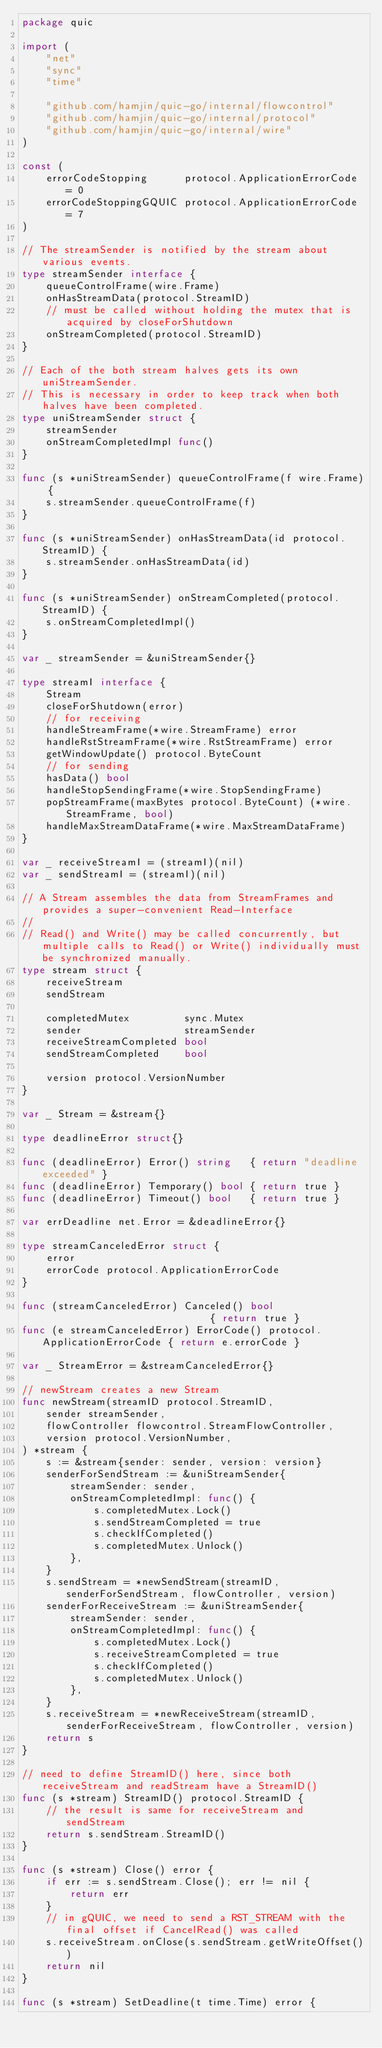<code> <loc_0><loc_0><loc_500><loc_500><_Go_>package quic

import (
	"net"
	"sync"
	"time"

	"github.com/hamjin/quic-go/internal/flowcontrol"
	"github.com/hamjin/quic-go/internal/protocol"
	"github.com/hamjin/quic-go/internal/wire"
)

const (
	errorCodeStopping      protocol.ApplicationErrorCode = 0
	errorCodeStoppingGQUIC protocol.ApplicationErrorCode = 7
)

// The streamSender is notified by the stream about various events.
type streamSender interface {
	queueControlFrame(wire.Frame)
	onHasStreamData(protocol.StreamID)
	// must be called without holding the mutex that is acquired by closeForShutdown
	onStreamCompleted(protocol.StreamID)
}

// Each of the both stream halves gets its own uniStreamSender.
// This is necessary in order to keep track when both halves have been completed.
type uniStreamSender struct {
	streamSender
	onStreamCompletedImpl func()
}

func (s *uniStreamSender) queueControlFrame(f wire.Frame) {
	s.streamSender.queueControlFrame(f)
}

func (s *uniStreamSender) onHasStreamData(id protocol.StreamID) {
	s.streamSender.onHasStreamData(id)
}

func (s *uniStreamSender) onStreamCompleted(protocol.StreamID) {
	s.onStreamCompletedImpl()
}

var _ streamSender = &uniStreamSender{}

type streamI interface {
	Stream
	closeForShutdown(error)
	// for receiving
	handleStreamFrame(*wire.StreamFrame) error
	handleRstStreamFrame(*wire.RstStreamFrame) error
	getWindowUpdate() protocol.ByteCount
	// for sending
	hasData() bool
	handleStopSendingFrame(*wire.StopSendingFrame)
	popStreamFrame(maxBytes protocol.ByteCount) (*wire.StreamFrame, bool)
	handleMaxStreamDataFrame(*wire.MaxStreamDataFrame)
}

var _ receiveStreamI = (streamI)(nil)
var _ sendStreamI = (streamI)(nil)

// A Stream assembles the data from StreamFrames and provides a super-convenient Read-Interface
//
// Read() and Write() may be called concurrently, but multiple calls to Read() or Write() individually must be synchronized manually.
type stream struct {
	receiveStream
	sendStream

	completedMutex         sync.Mutex
	sender                 streamSender
	receiveStreamCompleted bool
	sendStreamCompleted    bool

	version protocol.VersionNumber
}

var _ Stream = &stream{}

type deadlineError struct{}

func (deadlineError) Error() string   { return "deadline exceeded" }
func (deadlineError) Temporary() bool { return true }
func (deadlineError) Timeout() bool   { return true }

var errDeadline net.Error = &deadlineError{}

type streamCanceledError struct {
	error
	errorCode protocol.ApplicationErrorCode
}

func (streamCanceledError) Canceled() bool                             { return true }
func (e streamCanceledError) ErrorCode() protocol.ApplicationErrorCode { return e.errorCode }

var _ StreamError = &streamCanceledError{}

// newStream creates a new Stream
func newStream(streamID protocol.StreamID,
	sender streamSender,
	flowController flowcontrol.StreamFlowController,
	version protocol.VersionNumber,
) *stream {
	s := &stream{sender: sender, version: version}
	senderForSendStream := &uniStreamSender{
		streamSender: sender,
		onStreamCompletedImpl: func() {
			s.completedMutex.Lock()
			s.sendStreamCompleted = true
			s.checkIfCompleted()
			s.completedMutex.Unlock()
		},
	}
	s.sendStream = *newSendStream(streamID, senderForSendStream, flowController, version)
	senderForReceiveStream := &uniStreamSender{
		streamSender: sender,
		onStreamCompletedImpl: func() {
			s.completedMutex.Lock()
			s.receiveStreamCompleted = true
			s.checkIfCompleted()
			s.completedMutex.Unlock()
		},
	}
	s.receiveStream = *newReceiveStream(streamID, senderForReceiveStream, flowController, version)
	return s
}

// need to define StreamID() here, since both receiveStream and readStream have a StreamID()
func (s *stream) StreamID() protocol.StreamID {
	// the result is same for receiveStream and sendStream
	return s.sendStream.StreamID()
}

func (s *stream) Close() error {
	if err := s.sendStream.Close(); err != nil {
		return err
	}
	// in gQUIC, we need to send a RST_STREAM with the final offset if CancelRead() was called
	s.receiveStream.onClose(s.sendStream.getWriteOffset())
	return nil
}

func (s *stream) SetDeadline(t time.Time) error {</code> 